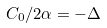<formula> <loc_0><loc_0><loc_500><loc_500>C _ { 0 } / 2 \alpha = - \Delta</formula> 